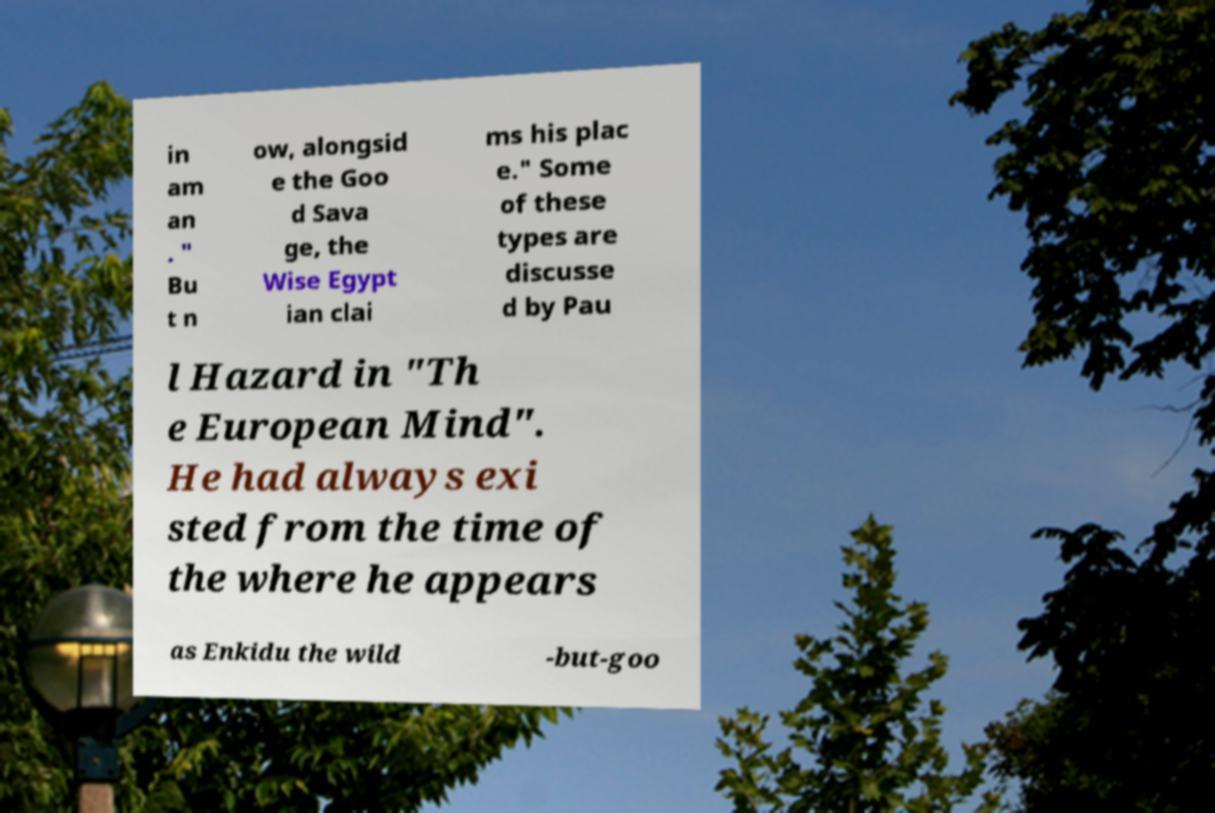There's text embedded in this image that I need extracted. Can you transcribe it verbatim? in am an . " Bu t n ow, alongsid e the Goo d Sava ge, the Wise Egypt ian clai ms his plac e." Some of these types are discusse d by Pau l Hazard in "Th e European Mind". He had always exi sted from the time of the where he appears as Enkidu the wild -but-goo 